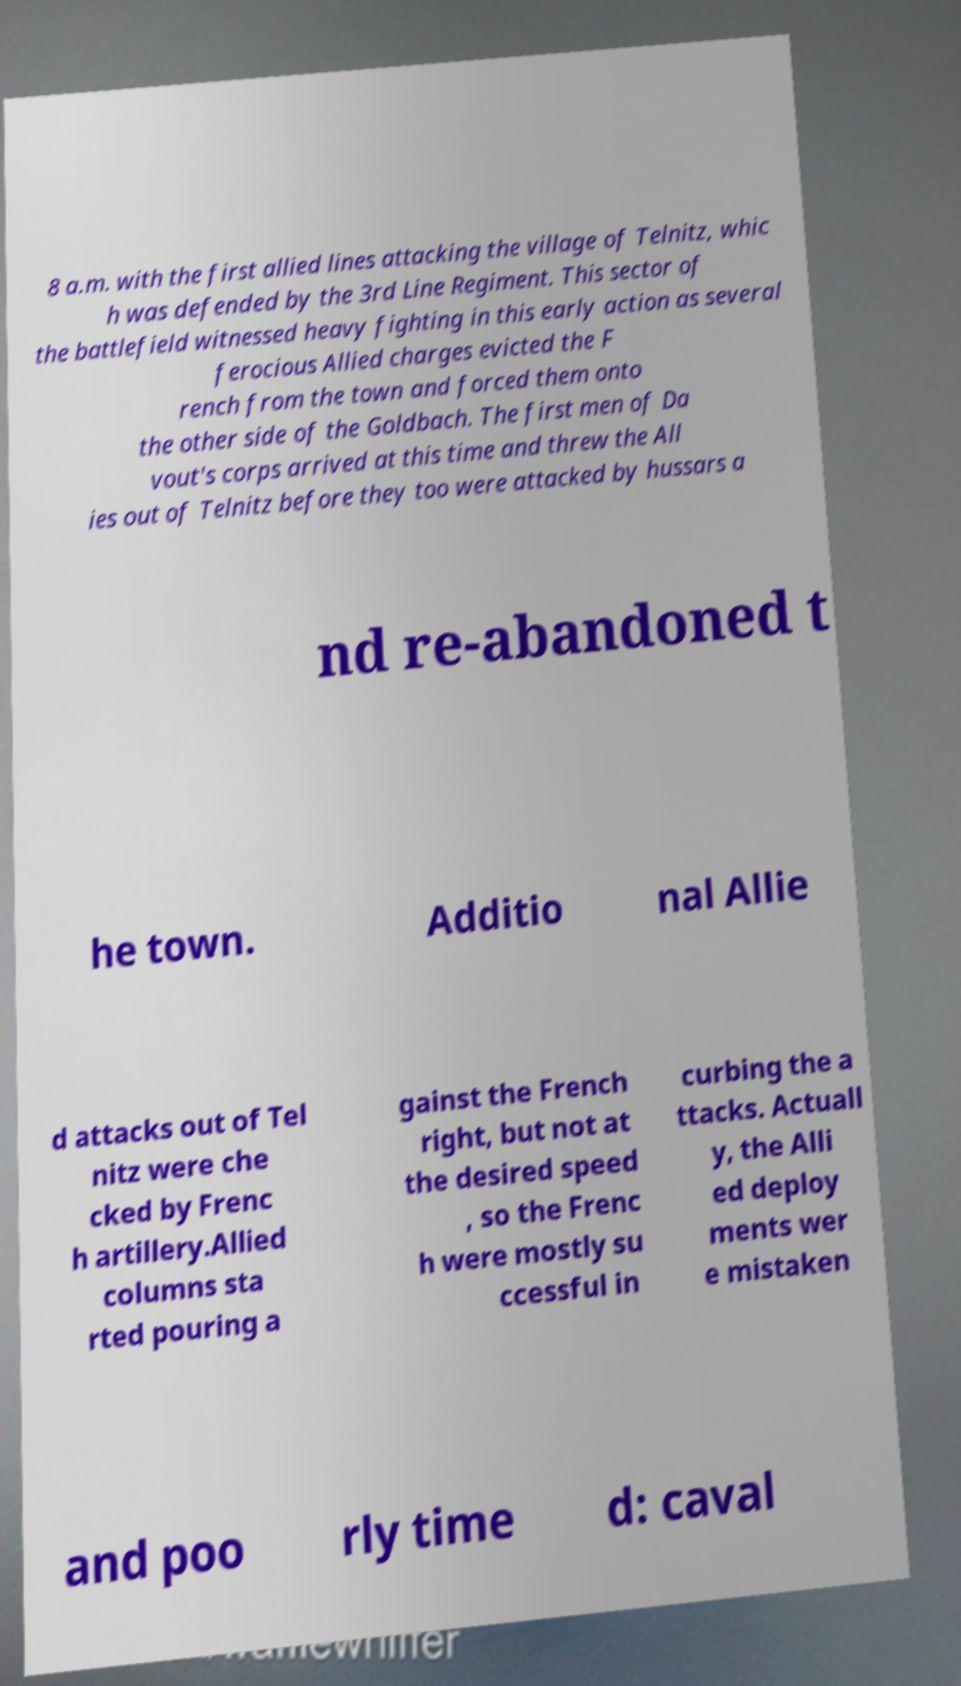Could you assist in decoding the text presented in this image and type it out clearly? 8 a.m. with the first allied lines attacking the village of Telnitz, whic h was defended by the 3rd Line Regiment. This sector of the battlefield witnessed heavy fighting in this early action as several ferocious Allied charges evicted the F rench from the town and forced them onto the other side of the Goldbach. The first men of Da vout's corps arrived at this time and threw the All ies out of Telnitz before they too were attacked by hussars a nd re-abandoned t he town. Additio nal Allie d attacks out of Tel nitz were che cked by Frenc h artillery.Allied columns sta rted pouring a gainst the French right, but not at the desired speed , so the Frenc h were mostly su ccessful in curbing the a ttacks. Actuall y, the Alli ed deploy ments wer e mistaken and poo rly time d: caval 